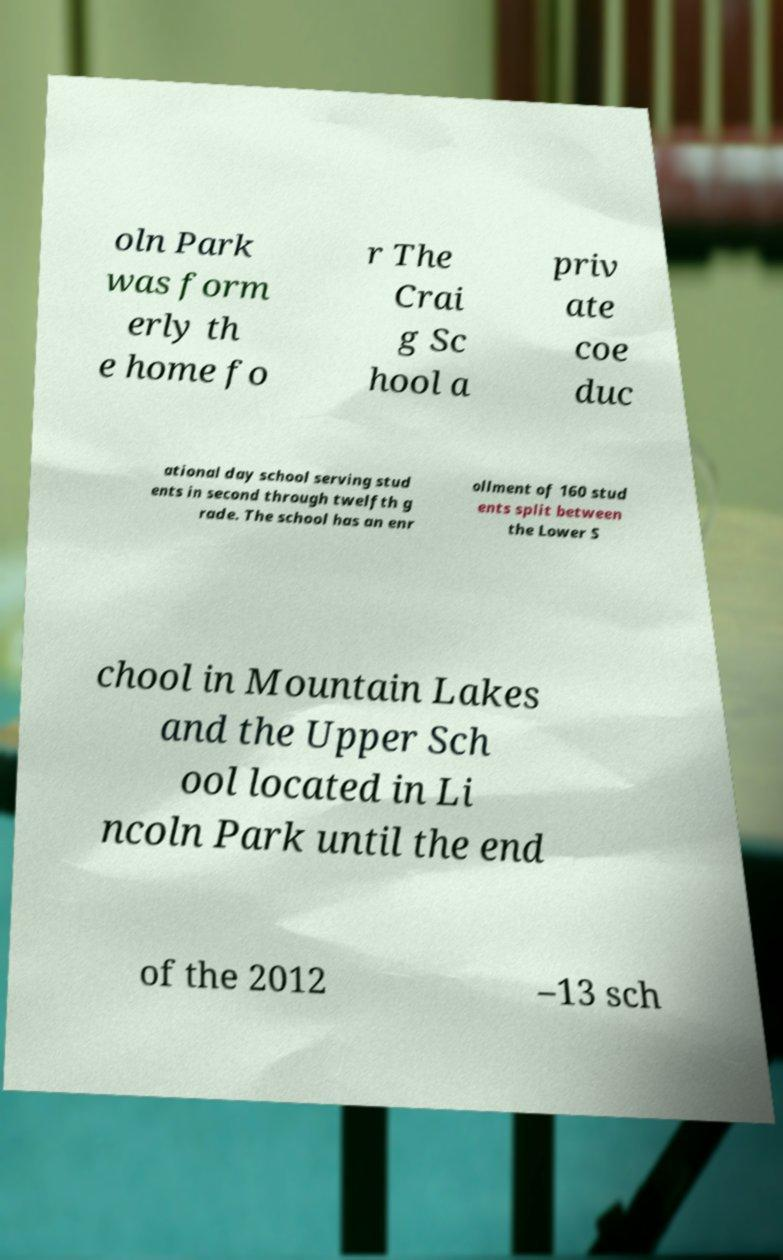Can you accurately transcribe the text from the provided image for me? oln Park was form erly th e home fo r The Crai g Sc hool a priv ate coe duc ational day school serving stud ents in second through twelfth g rade. The school has an enr ollment of 160 stud ents split between the Lower S chool in Mountain Lakes and the Upper Sch ool located in Li ncoln Park until the end of the 2012 –13 sch 